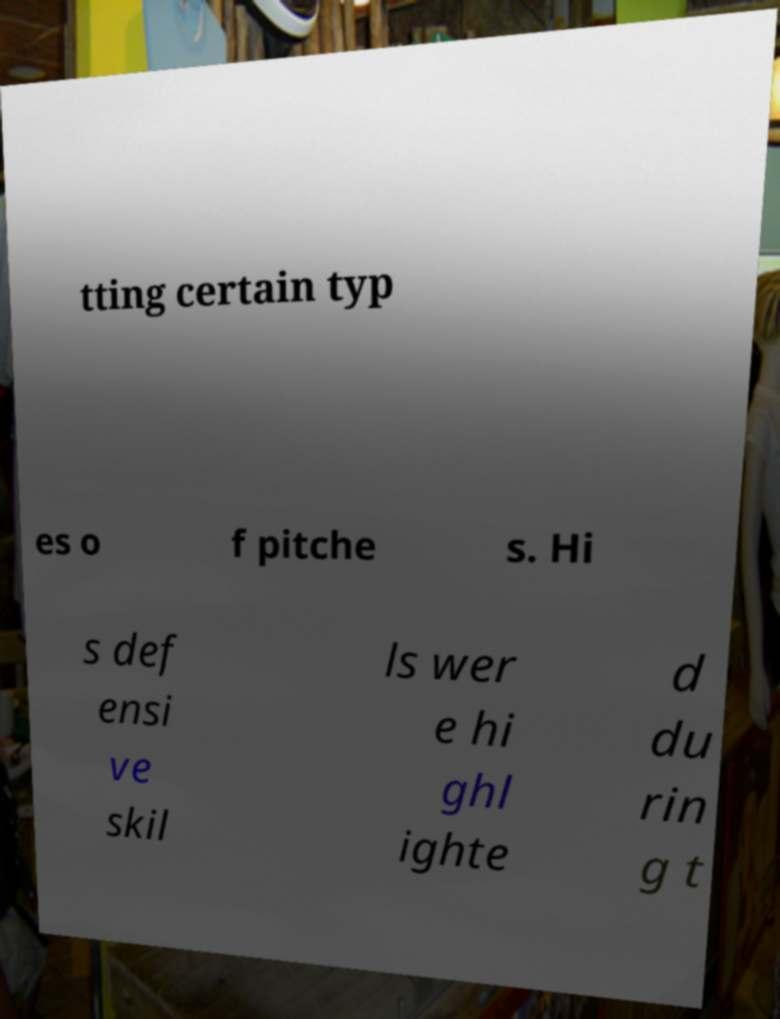I need the written content from this picture converted into text. Can you do that? tting certain typ es o f pitche s. Hi s def ensi ve skil ls wer e hi ghl ighte d du rin g t 